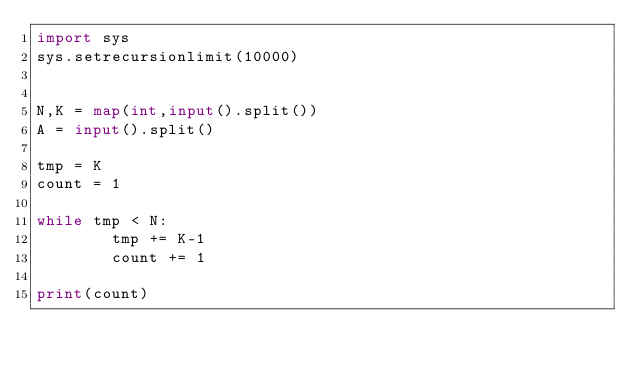<code> <loc_0><loc_0><loc_500><loc_500><_Python_>import sys
sys.setrecursionlimit(10000)


N,K = map(int,input().split())
A = input().split()

tmp = K
count = 1

while tmp < N:
        tmp += K-1
        count += 1

print(count)
</code> 